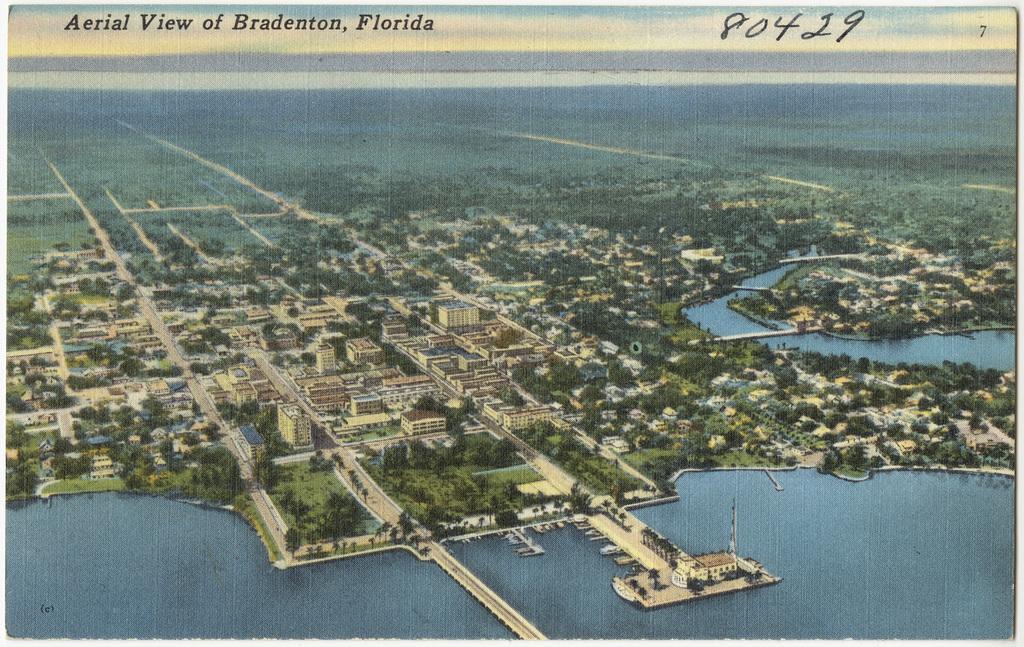How would you summarize this image in a sentence or two? In this image, in the middle there are buildings, trees, grass, water. At the top there is a text. 